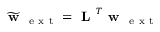<formula> <loc_0><loc_0><loc_500><loc_500>\widetilde { w } _ { e x t } = L ^ { T } w _ { e x t }</formula> 